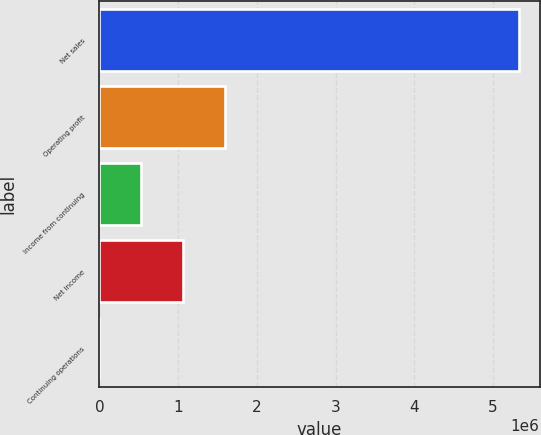Convert chart to OTSL. <chart><loc_0><loc_0><loc_500><loc_500><bar_chart><fcel>Net sales<fcel>Operating profit<fcel>Income from continuing<fcel>Net income<fcel>Continuing operations<nl><fcel>5.32475e+06<fcel>1.59742e+06<fcel>532476<fcel>1.06495e+06<fcel>1.01<nl></chart> 